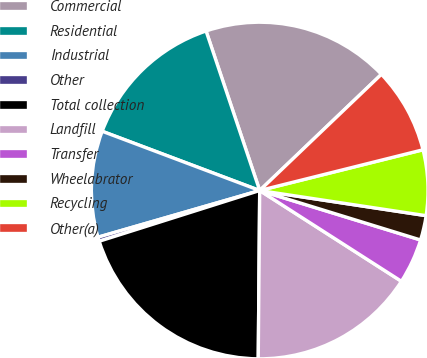Convert chart. <chart><loc_0><loc_0><loc_500><loc_500><pie_chart><fcel>Commercial<fcel>Residential<fcel>Industrial<fcel>Other<fcel>Total collection<fcel>Landfill<fcel>Transfer<fcel>Wheelabrator<fcel>Recycling<fcel>Other(a)<nl><fcel>18.03%<fcel>14.11%<fcel>10.2%<fcel>0.4%<fcel>19.99%<fcel>16.07%<fcel>4.32%<fcel>2.36%<fcel>6.28%<fcel>8.24%<nl></chart> 